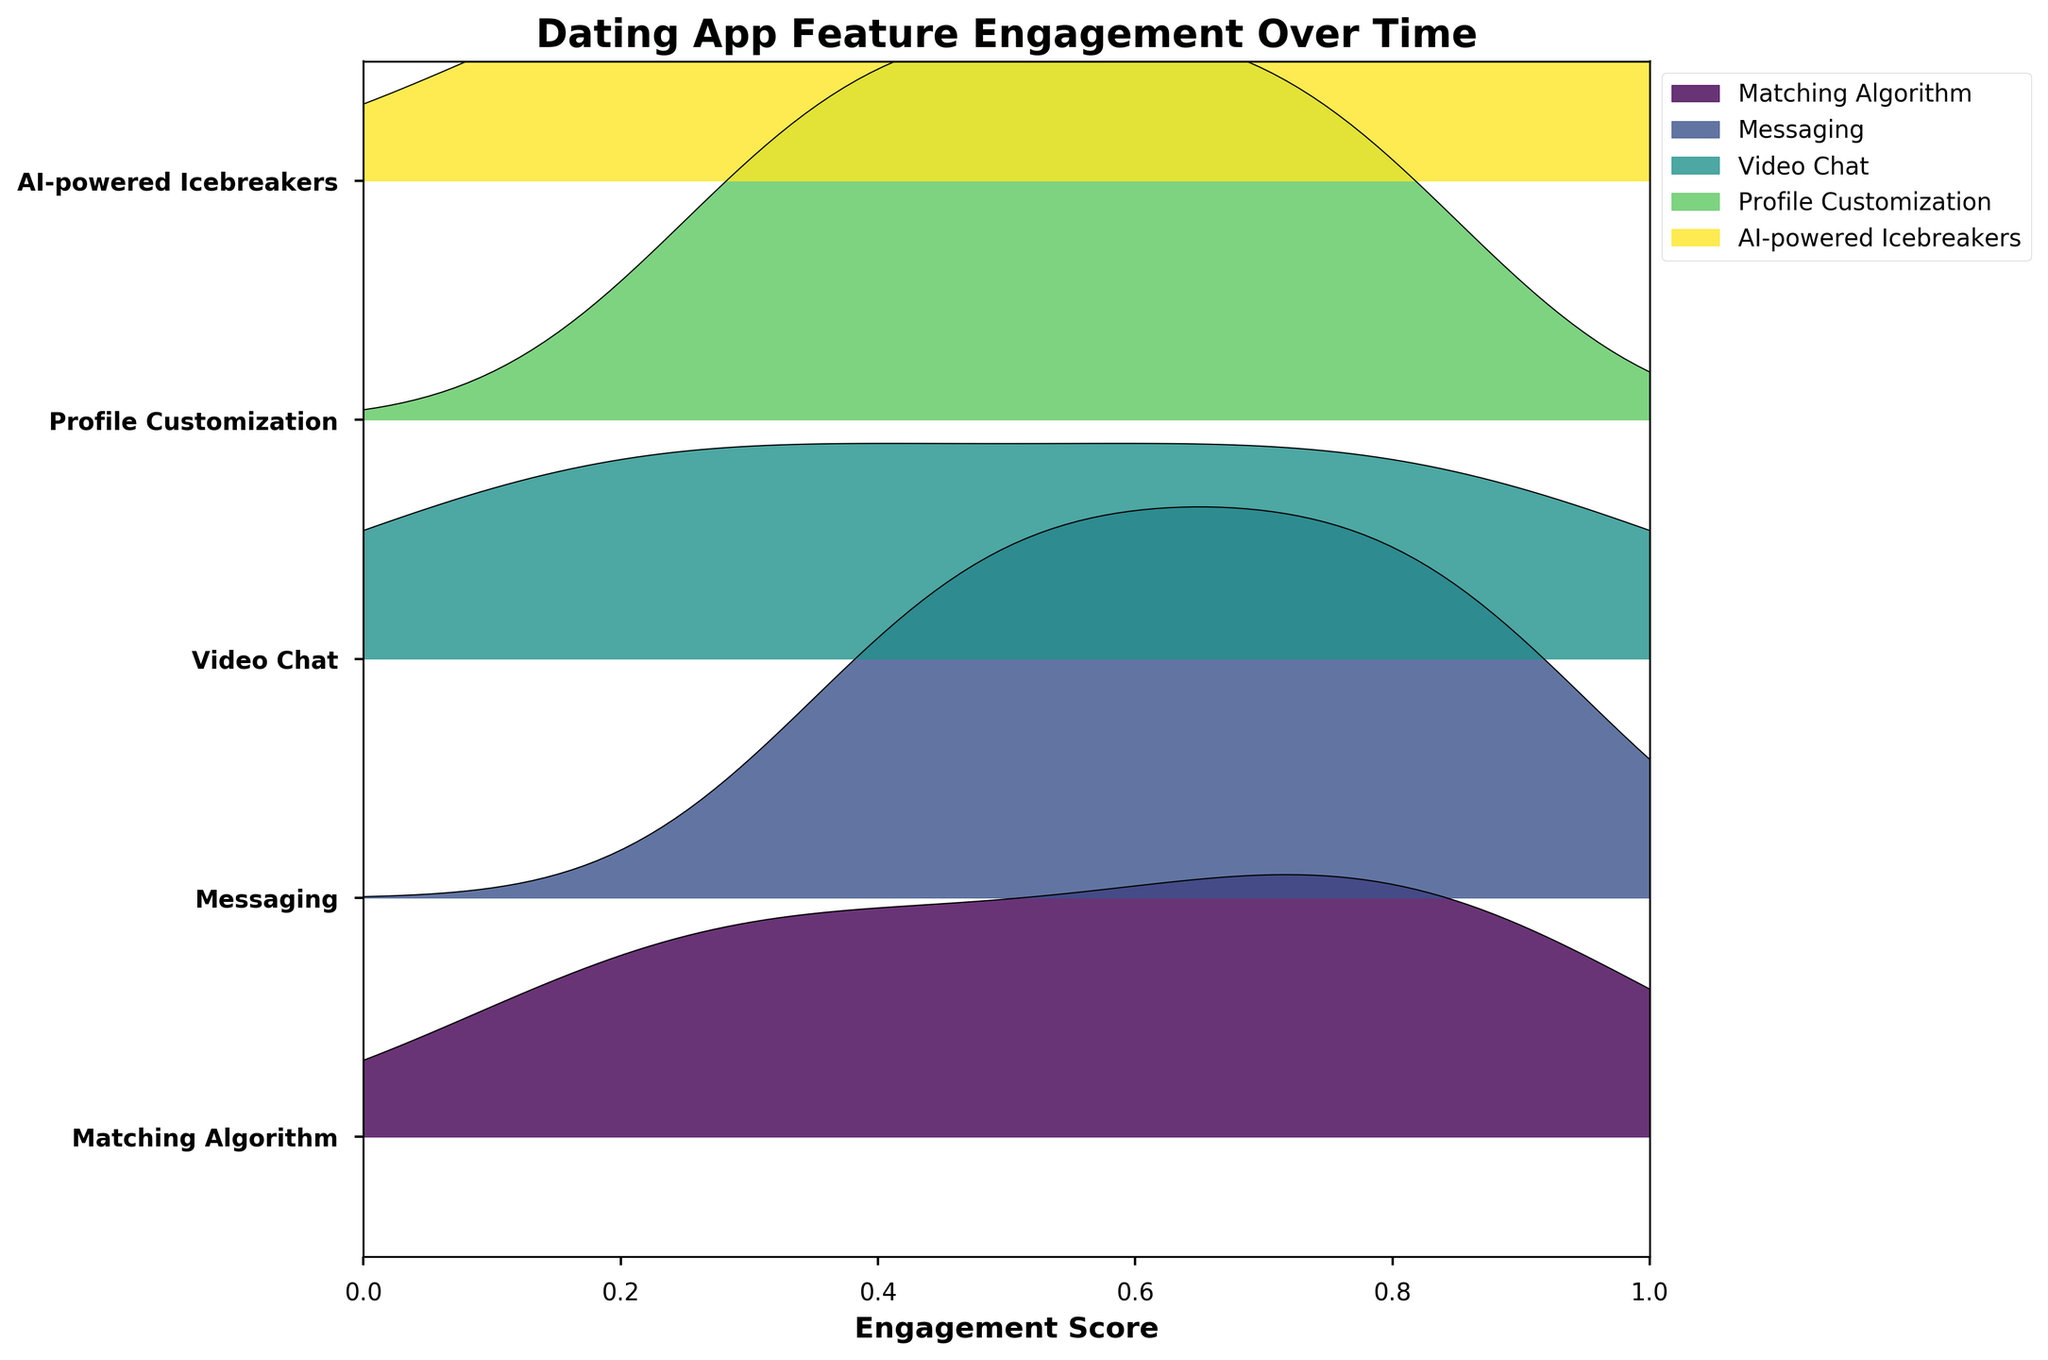What is the title of the figure? The title is typically found at the top of the plot and directly states what the figure represents. In this case, it's about engagement over time for dating app features.
Answer: Dating App Feature Engagement Over Time Which feature shows the highest engagement score consistently over time? To determine the highest engagement score consistently, observe the limiting points on the right end of the ridgeline plots, and look for the one that reaches or approaches 0.9 across all months.
Answer: Messaging and AI-powered Icebreakers Which feature has the lowest engagement score in January? Look at the leftmost points of the ridgelines for January and identify the lowest score.
Answer: Video Chat What is the average engagement score for the Matching Algorithm from Jan to Jun? The engagement scores for the Matching Algorithm from Jan to Jun are 0.2, 0.3, 0.5, 0.7, 0.8, and 0.9. Sum these values and divide by 6 to get the average. (0.2 + 0.3 + 0.5 + 0.7 + 0.8 + 0.9) / 6 = 3.4 / 6
Answer: 0.57 Which month shows the most significant increase in engagement score for the Video Chat feature? To identify this, compare the month-to-month changes in engagement scores (from Jan to Feb, Feb to Mar, etc.). The largest difference indicates the most significant increase.
Answer: May to Jun How does the engagement score trend for AI-powered Icebreakers compare to Profile Customization from Jan to Jun? Observe both ridgelines and their progression through months. While AI-powered Icebreakers and Profile Customization both increase, AI-powered Icebreakers tend to reach higher scores towards the later months.
Answer: AI-powered Icebreakers have a steeper increasing trend Considering ridgeline plots, which feature is least spread out in terms of engagement scores? Least spread out would mean less variation. Look for a ridgeline that has peaks close to the baseline without too much variance upwards or downwards.
Answer: Profile Customization By how much does the engagement score of Messaging increase from Jan to Jun? Check the engagement scores for Messaging from Jan and Jun. Subtract the initial month's score from the final month's score. 0.9 - 0.4
Answer: 0.5 Which feature shows the most variance in engagement scores over the months? The feature with the widest and highest peaks in the ridgeline plot indicates the most variance.
Answer: Matching Algorithm Which feature ends with the highest engagement score in Jun? Look at the engagement scores of all features in Jun and identify the one with the highest value.
Answer: Messaging, Video Chat, AI-powered Icebreakers, Matching Algorithm 